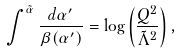Convert formula to latex. <formula><loc_0><loc_0><loc_500><loc_500>\int ^ { \tilde { \alpha } } \frac { d \alpha ^ { \prime } } { \beta ( \alpha ^ { \prime } ) } = \log \left ( \frac { Q ^ { 2 } } { \tilde { \Lambda } ^ { 2 } } \right ) ,</formula> 